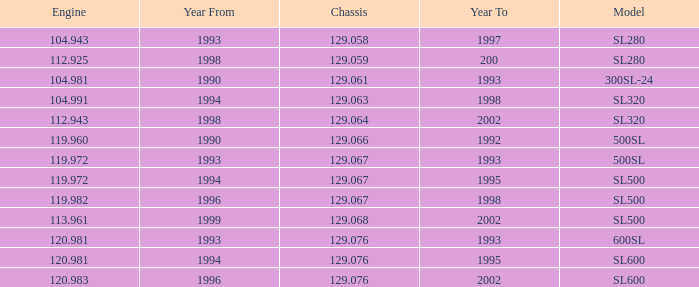I'm looking to parse the entire table for insights. Could you assist me with that? {'header': ['Engine', 'Year From', 'Chassis', 'Year To', 'Model'], 'rows': [['104.943', '1993', '129.058', '1997', 'SL280'], ['112.925', '1998', '129.059', '200', 'SL280'], ['104.981', '1990', '129.061', '1993', '300SL-24'], ['104.991', '1994', '129.063', '1998', 'SL320'], ['112.943', '1998', '129.064', '2002', 'SL320'], ['119.960', '1990', '129.066', '1992', '500SL'], ['119.972', '1993', '129.067', '1993', '500SL'], ['119.972', '1994', '129.067', '1995', 'SL500'], ['119.982', '1996', '129.067', '1998', 'SL500'], ['113.961', '1999', '129.068', '2002', 'SL500'], ['120.981', '1993', '129.076', '1993', '600SL'], ['120.981', '1994', '129.076', '1995', 'SL600'], ['120.983', '1996', '129.076', '2002', 'SL600']]} Which Engine has a Model of sl500, and a Chassis smaller than 129.067? None. 